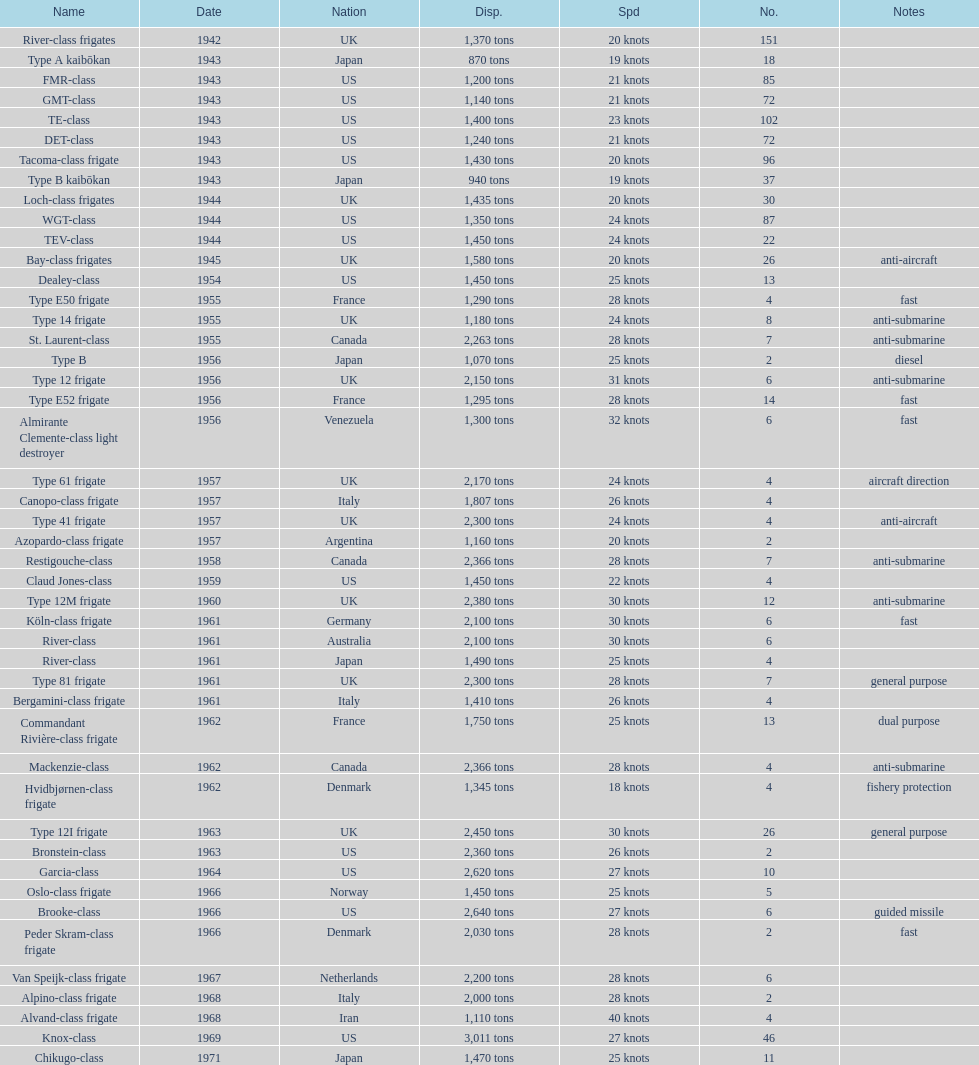Could you parse the entire table? {'header': ['Name', 'Date', 'Nation', 'Disp.', 'Spd', 'No.', 'Notes'], 'rows': [['River-class frigates', '1942', 'UK', '1,370 tons', '20 knots', '151', ''], ['Type A kaibōkan', '1943', 'Japan', '870 tons', '19 knots', '18', ''], ['FMR-class', '1943', 'US', '1,200 tons', '21 knots', '85', ''], ['GMT-class', '1943', 'US', '1,140 tons', '21 knots', '72', ''], ['TE-class', '1943', 'US', '1,400 tons', '23 knots', '102', ''], ['DET-class', '1943', 'US', '1,240 tons', '21 knots', '72', ''], ['Tacoma-class frigate', '1943', 'US', '1,430 tons', '20 knots', '96', ''], ['Type B kaibōkan', '1943', 'Japan', '940 tons', '19 knots', '37', ''], ['Loch-class frigates', '1944', 'UK', '1,435 tons', '20 knots', '30', ''], ['WGT-class', '1944', 'US', '1,350 tons', '24 knots', '87', ''], ['TEV-class', '1944', 'US', '1,450 tons', '24 knots', '22', ''], ['Bay-class frigates', '1945', 'UK', '1,580 tons', '20 knots', '26', 'anti-aircraft'], ['Dealey-class', '1954', 'US', '1,450 tons', '25 knots', '13', ''], ['Type E50 frigate', '1955', 'France', '1,290 tons', '28 knots', '4', 'fast'], ['Type 14 frigate', '1955', 'UK', '1,180 tons', '24 knots', '8', 'anti-submarine'], ['St. Laurent-class', '1955', 'Canada', '2,263 tons', '28 knots', '7', 'anti-submarine'], ['Type B', '1956', 'Japan', '1,070 tons', '25 knots', '2', 'diesel'], ['Type 12 frigate', '1956', 'UK', '2,150 tons', '31 knots', '6', 'anti-submarine'], ['Type E52 frigate', '1956', 'France', '1,295 tons', '28 knots', '14', 'fast'], ['Almirante Clemente-class light destroyer', '1956', 'Venezuela', '1,300 tons', '32 knots', '6', 'fast'], ['Type 61 frigate', '1957', 'UK', '2,170 tons', '24 knots', '4', 'aircraft direction'], ['Canopo-class frigate', '1957', 'Italy', '1,807 tons', '26 knots', '4', ''], ['Type 41 frigate', '1957', 'UK', '2,300 tons', '24 knots', '4', 'anti-aircraft'], ['Azopardo-class frigate', '1957', 'Argentina', '1,160 tons', '20 knots', '2', ''], ['Restigouche-class', '1958', 'Canada', '2,366 tons', '28 knots', '7', 'anti-submarine'], ['Claud Jones-class', '1959', 'US', '1,450 tons', '22 knots', '4', ''], ['Type 12M frigate', '1960', 'UK', '2,380 tons', '30 knots', '12', 'anti-submarine'], ['Köln-class frigate', '1961', 'Germany', '2,100 tons', '30 knots', '6', 'fast'], ['River-class', '1961', 'Australia', '2,100 tons', '30 knots', '6', ''], ['River-class', '1961', 'Japan', '1,490 tons', '25 knots', '4', ''], ['Type 81 frigate', '1961', 'UK', '2,300 tons', '28 knots', '7', 'general purpose'], ['Bergamini-class frigate', '1961', 'Italy', '1,410 tons', '26 knots', '4', ''], ['Commandant Rivière-class frigate', '1962', 'France', '1,750 tons', '25 knots', '13', 'dual purpose'], ['Mackenzie-class', '1962', 'Canada', '2,366 tons', '28 knots', '4', 'anti-submarine'], ['Hvidbjørnen-class frigate', '1962', 'Denmark', '1,345 tons', '18 knots', '4', 'fishery protection'], ['Type 12I frigate', '1963', 'UK', '2,450 tons', '30 knots', '26', 'general purpose'], ['Bronstein-class', '1963', 'US', '2,360 tons', '26 knots', '2', ''], ['Garcia-class', '1964', 'US', '2,620 tons', '27 knots', '10', ''], ['Oslo-class frigate', '1966', 'Norway', '1,450 tons', '25 knots', '5', ''], ['Brooke-class', '1966', 'US', '2,640 tons', '27 knots', '6', 'guided missile'], ['Peder Skram-class frigate', '1966', 'Denmark', '2,030 tons', '28 knots', '2', 'fast'], ['Van Speijk-class frigate', '1967', 'Netherlands', '2,200 tons', '28 knots', '6', ''], ['Alpino-class frigate', '1968', 'Italy', '2,000 tons', '28 knots', '2', ''], ['Alvand-class frigate', '1968', 'Iran', '1,110 tons', '40 knots', '4', ''], ['Knox-class', '1969', 'US', '3,011 tons', '27 knots', '46', ''], ['Chikugo-class', '1971', 'Japan', '1,470 tons', '25 knots', '11', '']]} How many tons of displacement does type b have? 940 tons. 